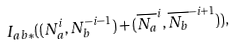<formula> <loc_0><loc_0><loc_500><loc_500>I _ { a b * } ( ( N _ { a } ^ { i } , N _ { b } ^ { - i - 1 } ) + ( \overline { N _ { a } } ^ { i } , \overline { N _ { b } } ^ { - i + 1 } ) ) ,</formula> 